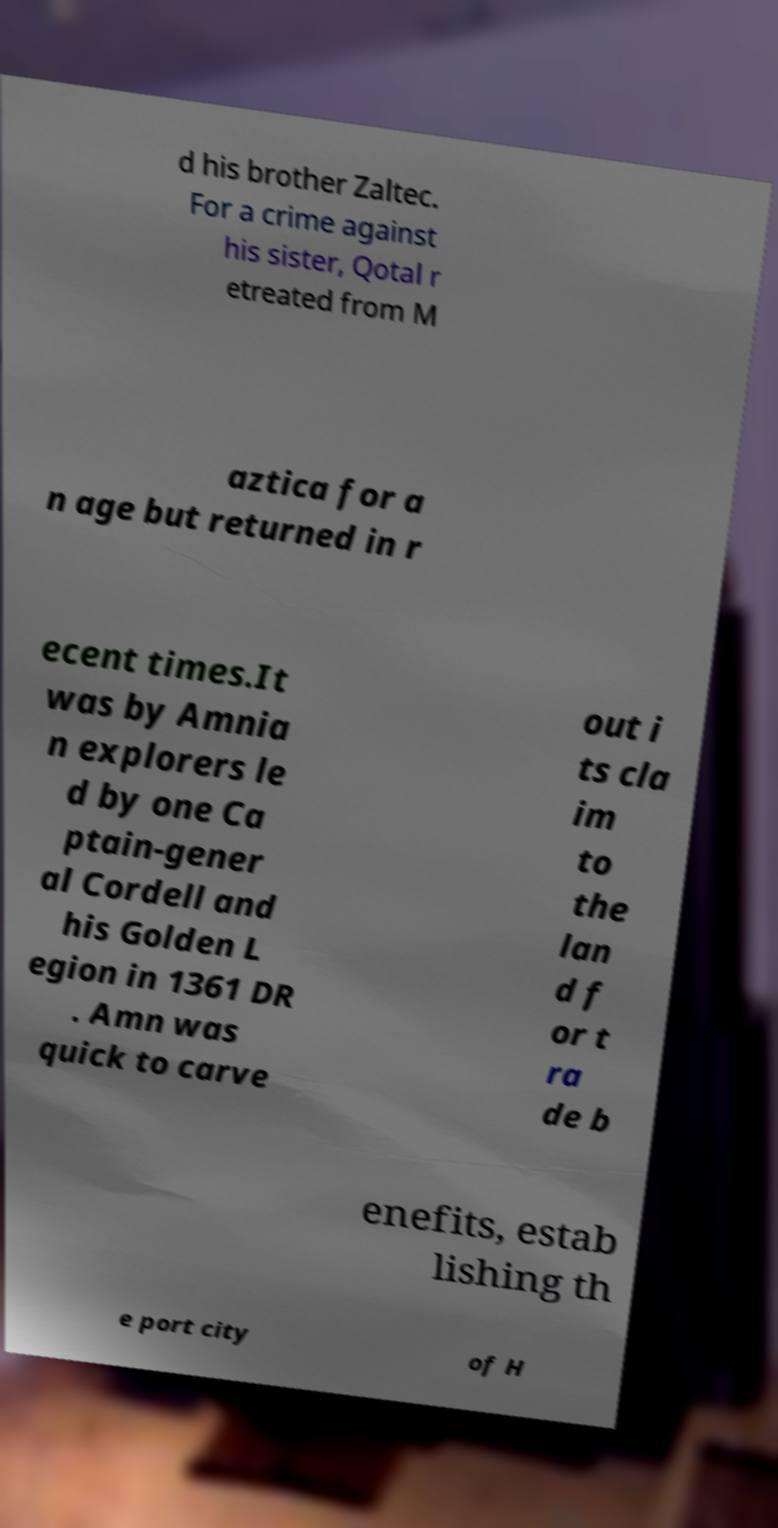I need the written content from this picture converted into text. Can you do that? d his brother Zaltec. For a crime against his sister, Qotal r etreated from M aztica for a n age but returned in r ecent times.It was by Amnia n explorers le d by one Ca ptain-gener al Cordell and his Golden L egion in 1361 DR . Amn was quick to carve out i ts cla im to the lan d f or t ra de b enefits, estab lishing th e port city of H 